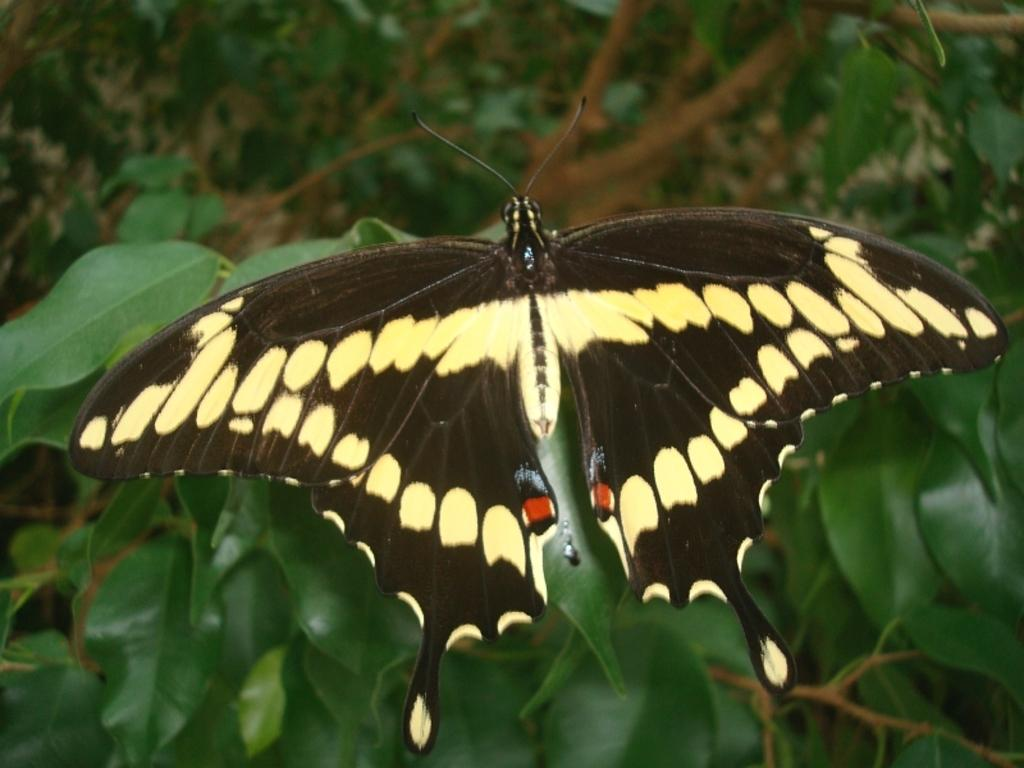What is the main subject of the image? The main subject of the image is a butterfly. Can you describe the appearance of the butterfly? The butterfly is black and yellow in color. Where is the butterfly located in the image? The butterfly is flying on the leaves. What type of calculator is the butterfly using to perform calculations in the image? There is no calculator present in the image, and butterflies do not use calculators. 